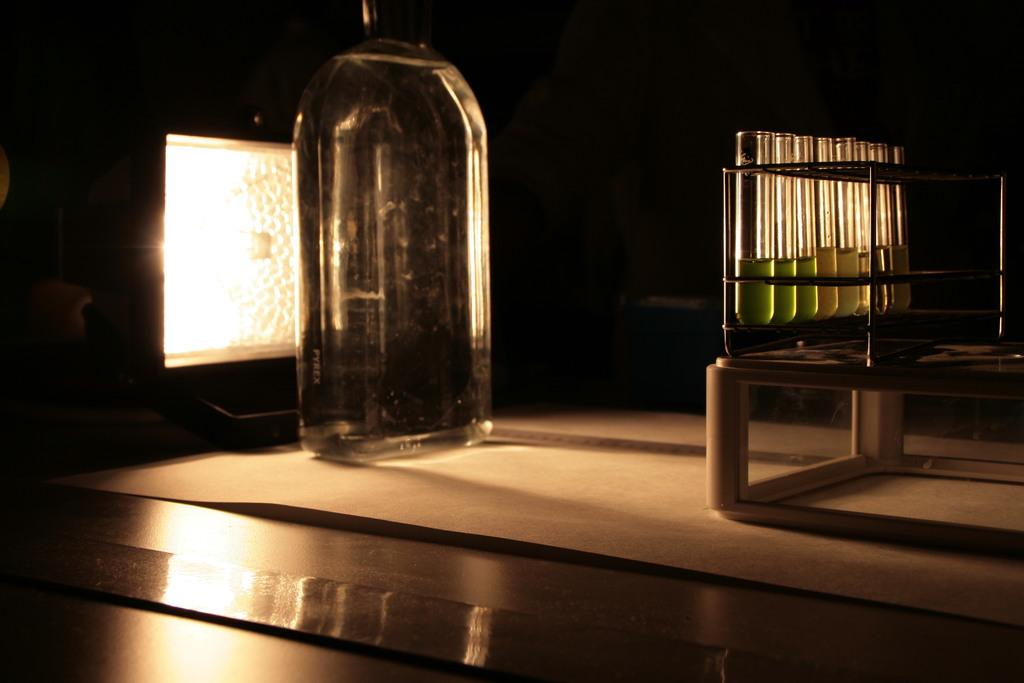What type of containers can be seen in the image? There are small test tubes and a glass bottle in the image. Can you describe the size of the test tubes? The test tubes are small in size. How many ladybugs are crawling on the glass bottle in the image? There are no ladybugs present in the image; it only features small test tubes and a glass bottle. 